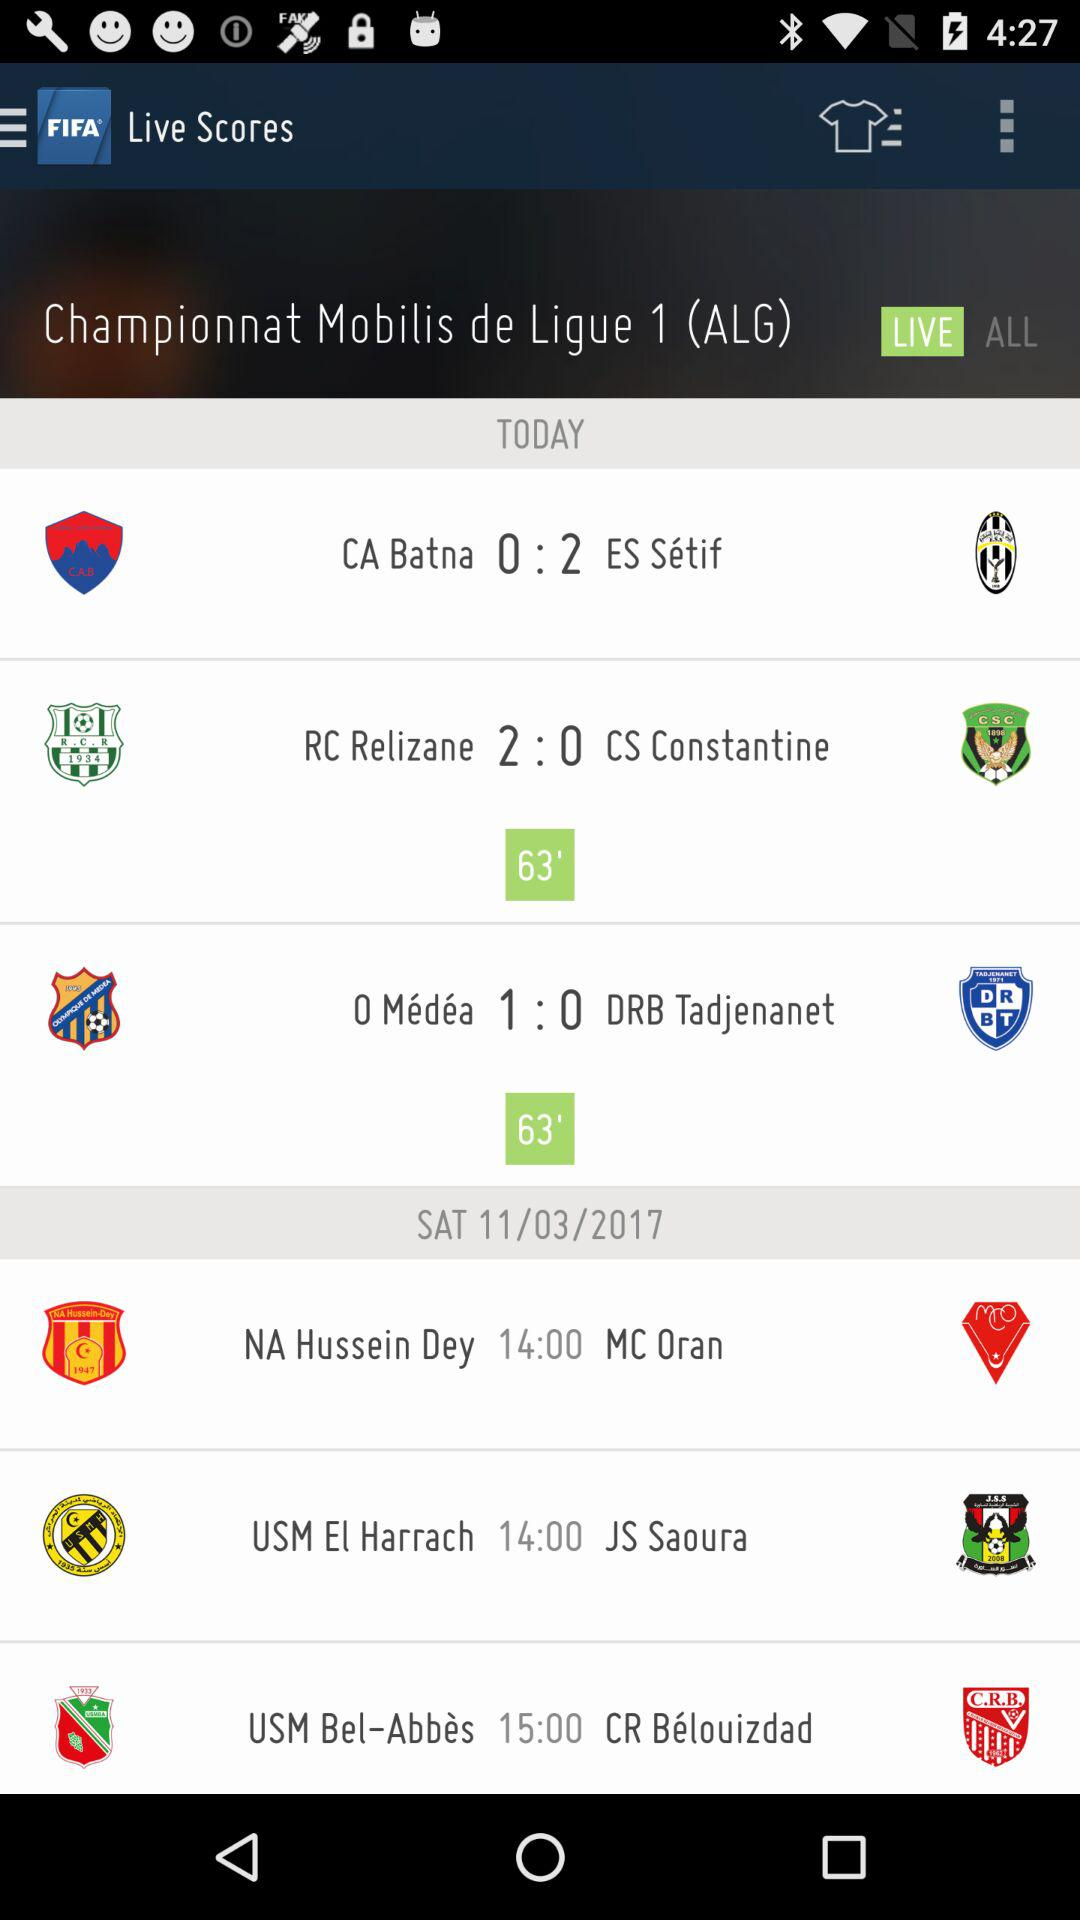Which team won the match today?
When the provided information is insufficient, respond with <no answer>. <no answer> 